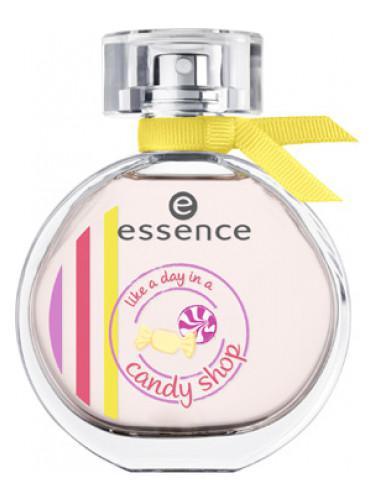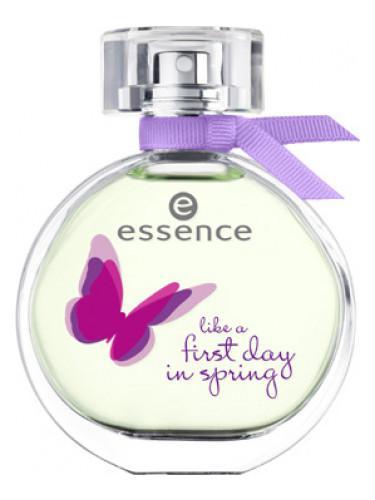The first image is the image on the left, the second image is the image on the right. Analyze the images presented: Is the assertion "the bottle on the right is pink." valid? Answer yes or no. No. 